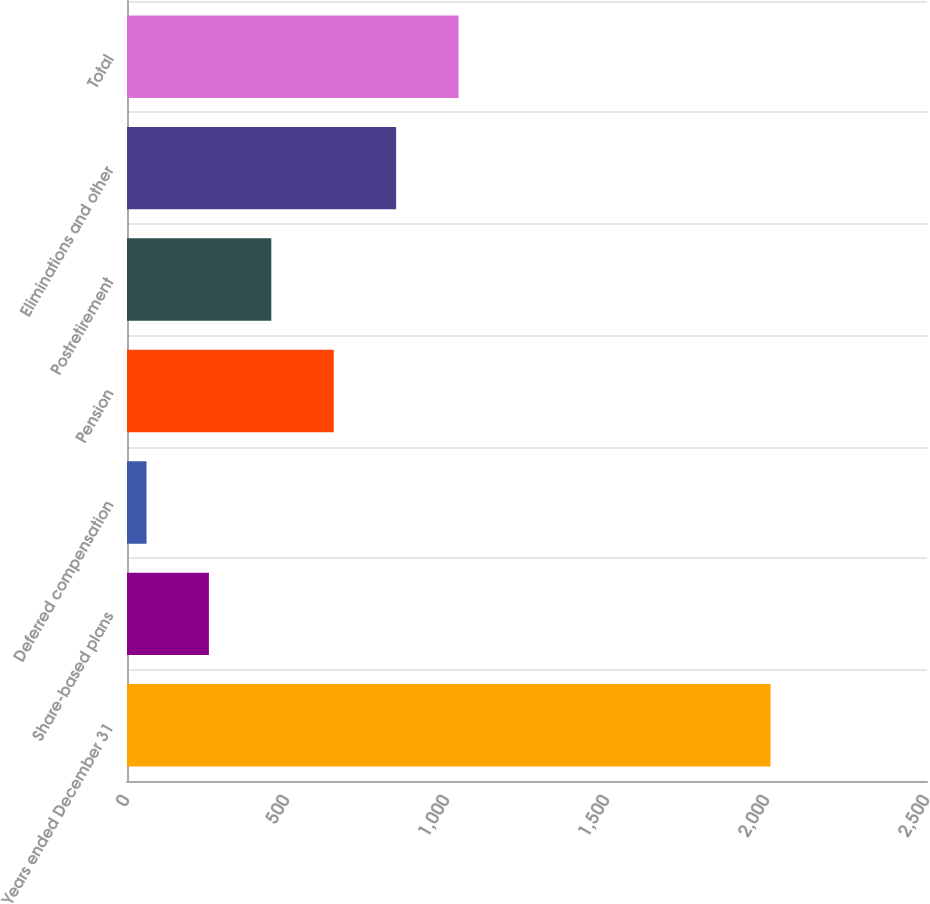<chart> <loc_0><loc_0><loc_500><loc_500><bar_chart><fcel>Years ended December 31<fcel>Share-based plans<fcel>Deferred compensation<fcel>Pension<fcel>Postretirement<fcel>Eliminations and other<fcel>Total<nl><fcel>2011<fcel>256<fcel>61<fcel>646<fcel>451<fcel>841<fcel>1036<nl></chart> 